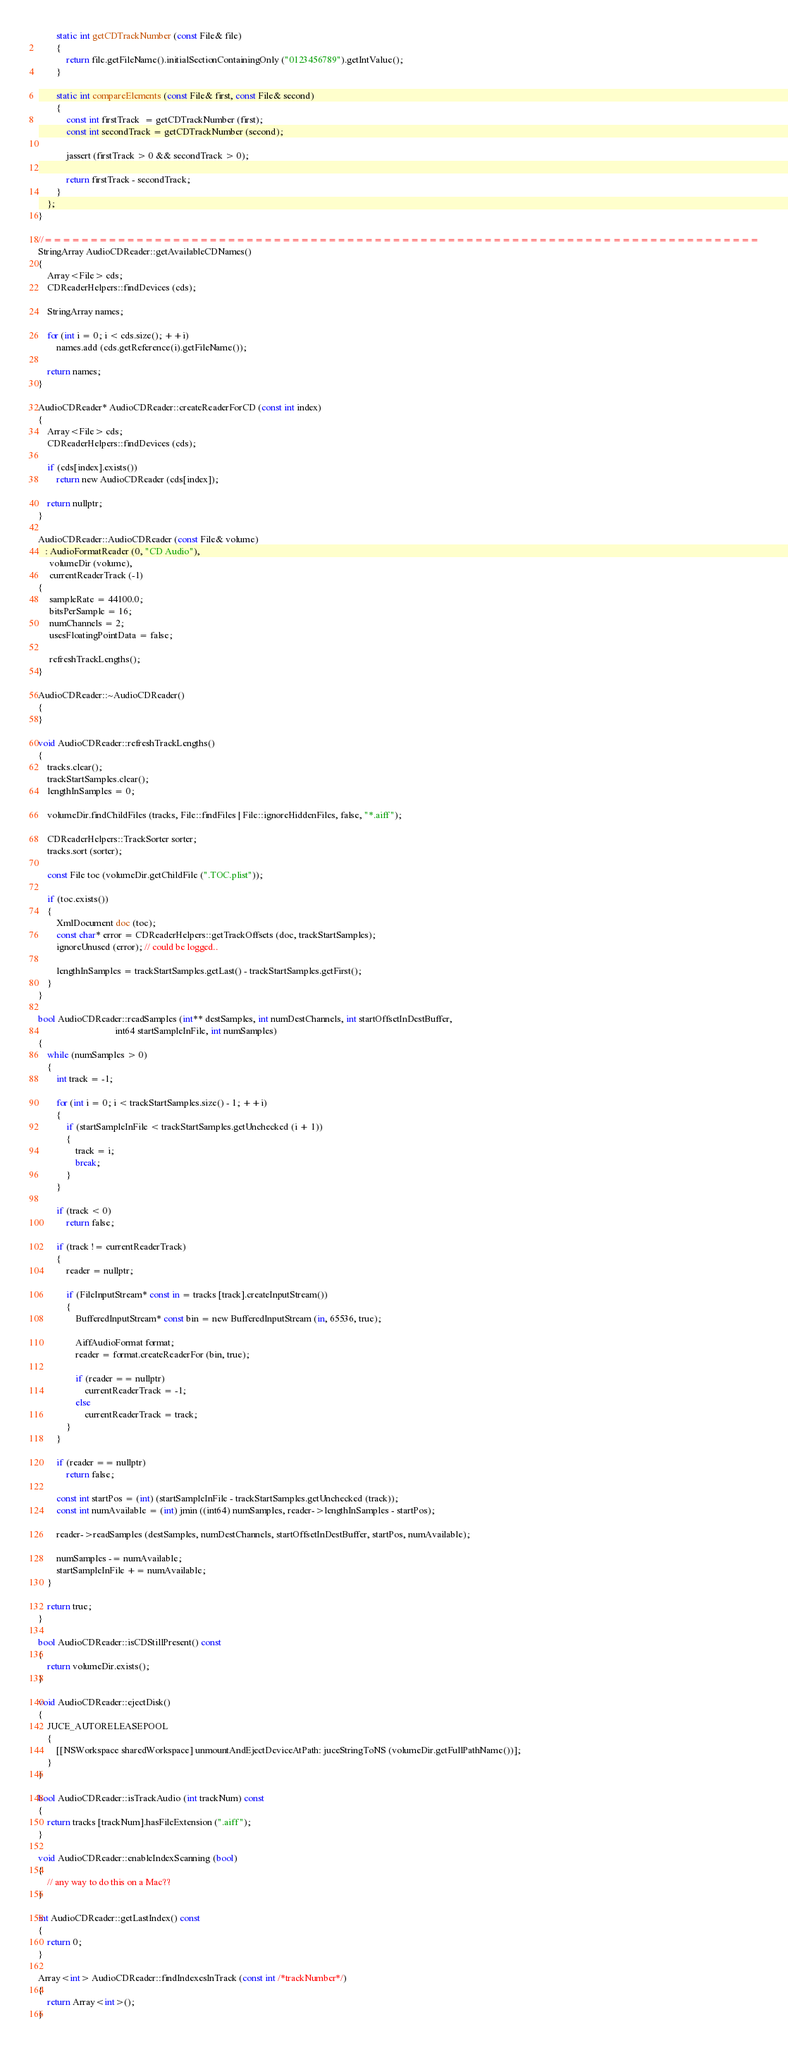Convert code to text. <code><loc_0><loc_0><loc_500><loc_500><_ObjectiveC_>        static int getCDTrackNumber (const File& file)
        {
            return file.getFileName().initialSectionContainingOnly ("0123456789").getIntValue();
        }

        static int compareElements (const File& first, const File& second)
        {
            const int firstTrack  = getCDTrackNumber (first);
            const int secondTrack = getCDTrackNumber (second);

            jassert (firstTrack > 0 && secondTrack > 0);

            return firstTrack - secondTrack;
        }
    };
}

//==============================================================================
StringArray AudioCDReader::getAvailableCDNames()
{
    Array<File> cds;
    CDReaderHelpers::findDevices (cds);

    StringArray names;

    for (int i = 0; i < cds.size(); ++i)
        names.add (cds.getReference(i).getFileName());

    return names;
}

AudioCDReader* AudioCDReader::createReaderForCD (const int index)
{
    Array<File> cds;
    CDReaderHelpers::findDevices (cds);

    if (cds[index].exists())
        return new AudioCDReader (cds[index]);

    return nullptr;
}

AudioCDReader::AudioCDReader (const File& volume)
   : AudioFormatReader (0, "CD Audio"),
     volumeDir (volume),
     currentReaderTrack (-1)
{
     sampleRate = 44100.0;
     bitsPerSample = 16;
     numChannels = 2;
     usesFloatingPointData = false;

     refreshTrackLengths();
}

AudioCDReader::~AudioCDReader()
{
}

void AudioCDReader::refreshTrackLengths()
{
    tracks.clear();
    trackStartSamples.clear();
    lengthInSamples = 0;

    volumeDir.findChildFiles (tracks, File::findFiles | File::ignoreHiddenFiles, false, "*.aiff");

    CDReaderHelpers::TrackSorter sorter;
    tracks.sort (sorter);

    const File toc (volumeDir.getChildFile (".TOC.plist"));

    if (toc.exists())
    {
        XmlDocument doc (toc);
        const char* error = CDReaderHelpers::getTrackOffsets (doc, trackStartSamples);
        ignoreUnused (error); // could be logged..

        lengthInSamples = trackStartSamples.getLast() - trackStartSamples.getFirst();
    }
}

bool AudioCDReader::readSamples (int** destSamples, int numDestChannels, int startOffsetInDestBuffer,
                                 int64 startSampleInFile, int numSamples)
{
    while (numSamples > 0)
    {
        int track = -1;

        for (int i = 0; i < trackStartSamples.size() - 1; ++i)
        {
            if (startSampleInFile < trackStartSamples.getUnchecked (i + 1))
            {
                track = i;
                break;
            }
        }

        if (track < 0)
            return false;

        if (track != currentReaderTrack)
        {
            reader = nullptr;

            if (FileInputStream* const in = tracks [track].createInputStream())
            {
                BufferedInputStream* const bin = new BufferedInputStream (in, 65536, true);

                AiffAudioFormat format;
                reader = format.createReaderFor (bin, true);

                if (reader == nullptr)
                    currentReaderTrack = -1;
                else
                    currentReaderTrack = track;
            }
        }

        if (reader == nullptr)
            return false;

        const int startPos = (int) (startSampleInFile - trackStartSamples.getUnchecked (track));
        const int numAvailable = (int) jmin ((int64) numSamples, reader->lengthInSamples - startPos);

        reader->readSamples (destSamples, numDestChannels, startOffsetInDestBuffer, startPos, numAvailable);

        numSamples -= numAvailable;
        startSampleInFile += numAvailable;
    }

    return true;
}

bool AudioCDReader::isCDStillPresent() const
{
    return volumeDir.exists();
}

void AudioCDReader::ejectDisk()
{
    JUCE_AUTORELEASEPOOL
    {
        [[NSWorkspace sharedWorkspace] unmountAndEjectDeviceAtPath: juceStringToNS (volumeDir.getFullPathName())];
    }
}

bool AudioCDReader::isTrackAudio (int trackNum) const
{
    return tracks [trackNum].hasFileExtension (".aiff");
}

void AudioCDReader::enableIndexScanning (bool)
{
    // any way to do this on a Mac??
}

int AudioCDReader::getLastIndex() const
{
    return 0;
}

Array<int> AudioCDReader::findIndexesInTrack (const int /*trackNumber*/)
{
    return Array<int>();
}
</code> 